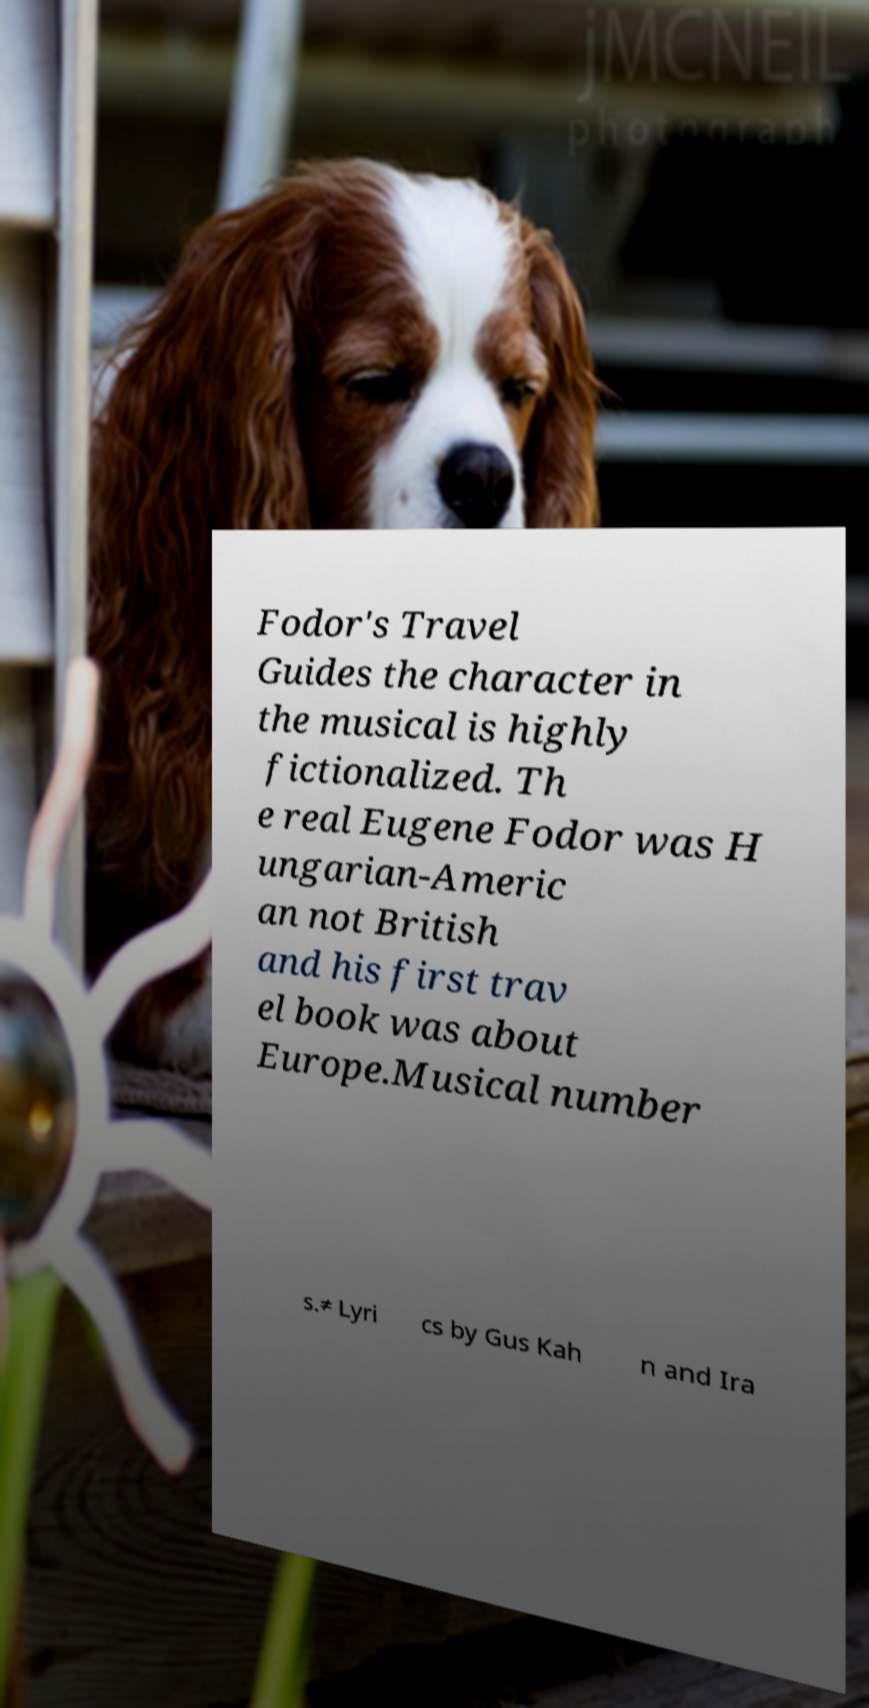Can you accurately transcribe the text from the provided image for me? Fodor's Travel Guides the character in the musical is highly fictionalized. Th e real Eugene Fodor was H ungarian-Americ an not British and his first trav el book was about Europe.Musical number s.≠ Lyri cs by Gus Kah n and Ira 